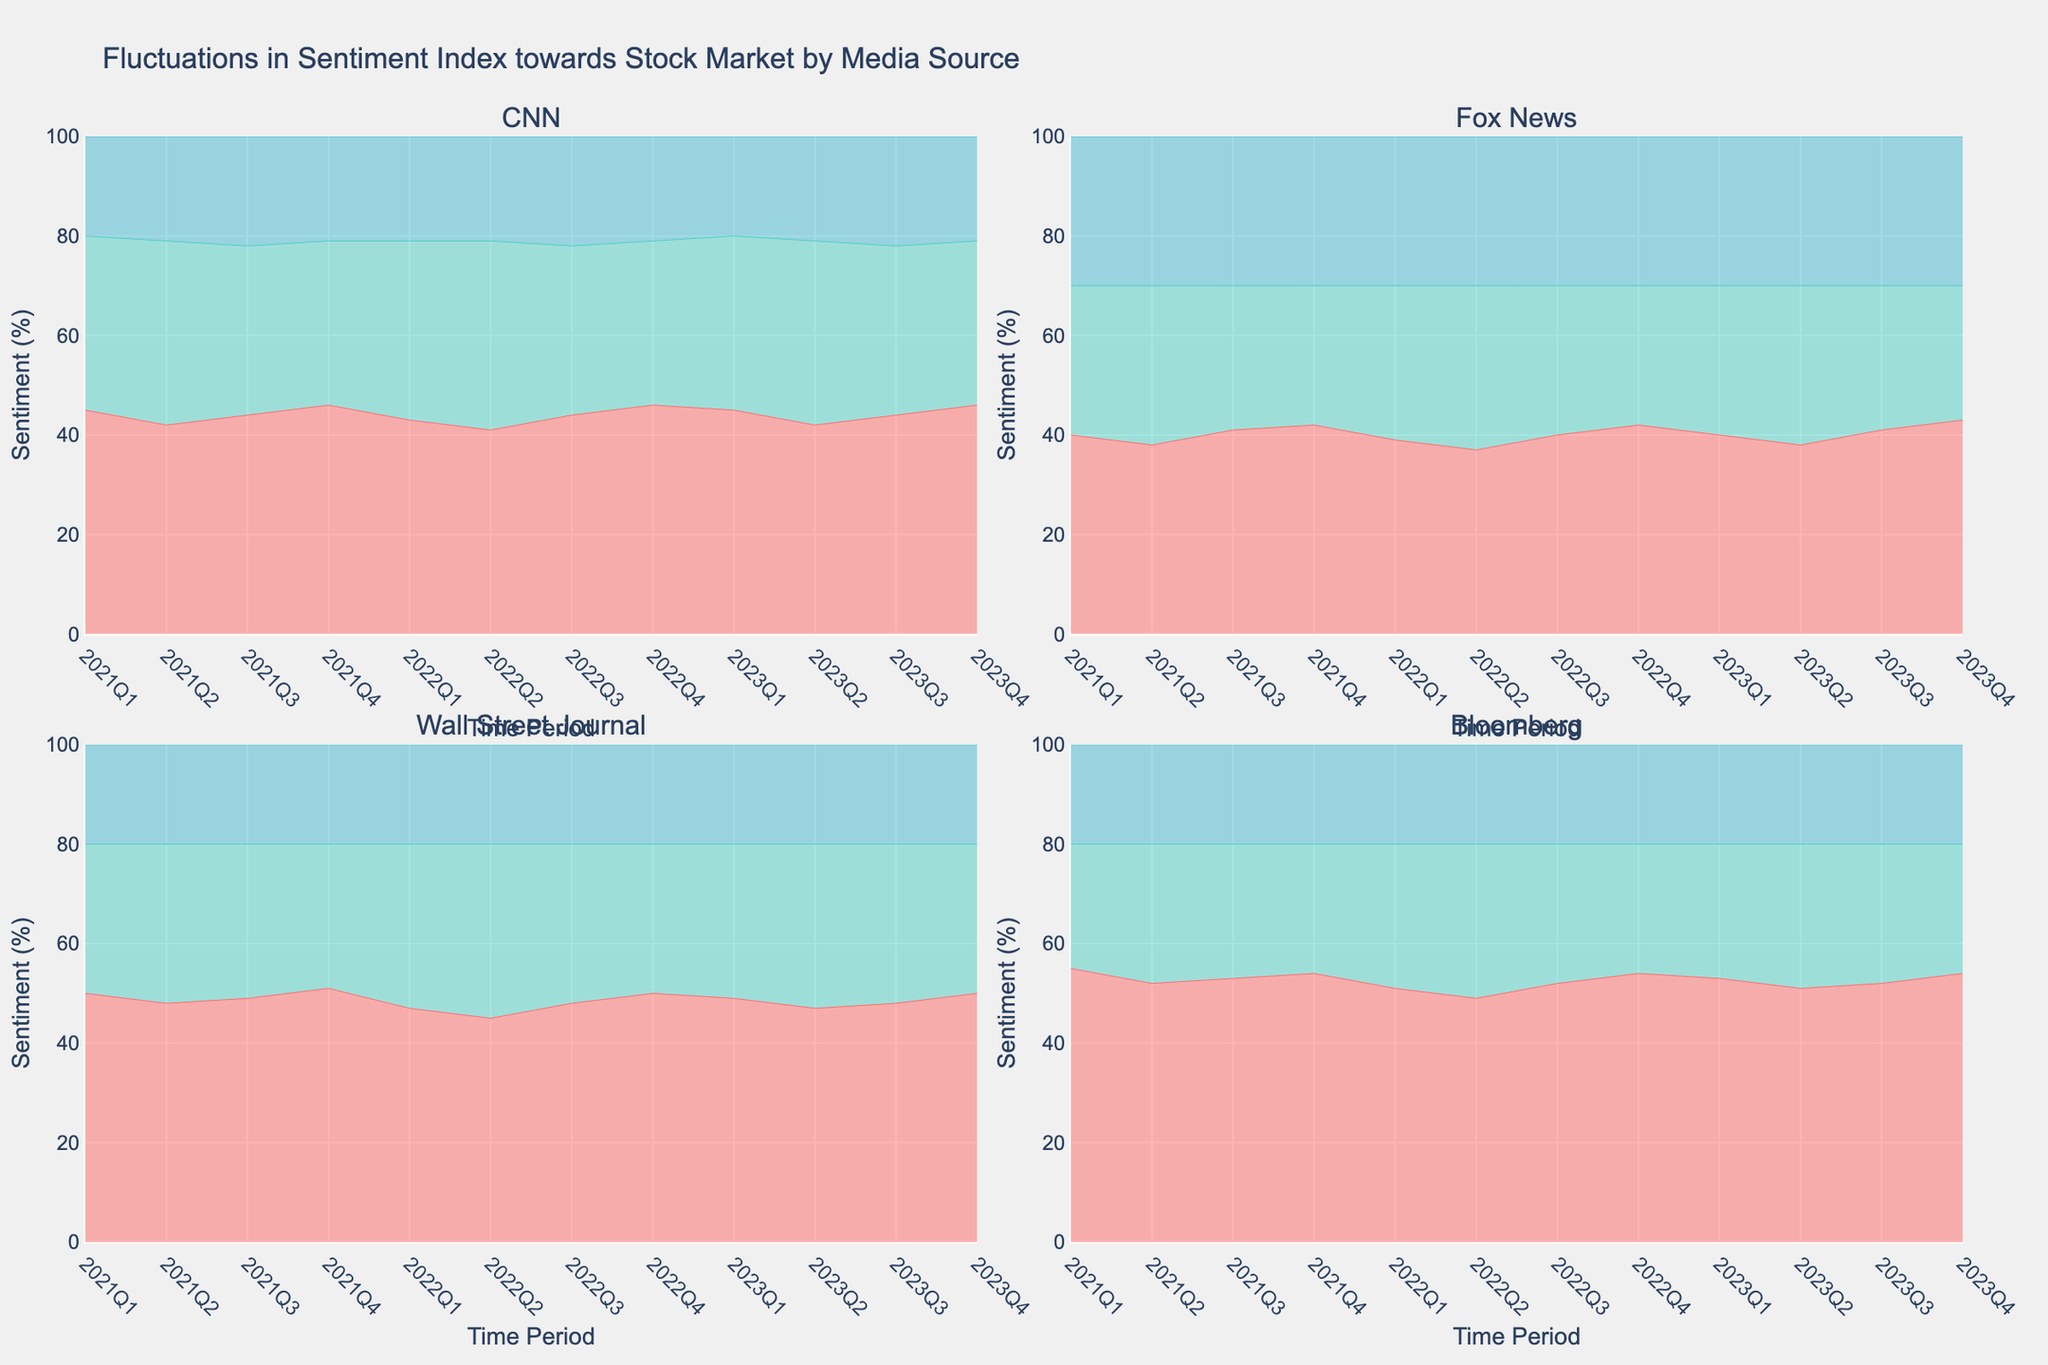What is the title of the figure? The title is found at the top of the figure, providing an overview of the visual content. It states the primary focus of the data analyzed in the subplots.
Answer: Fluctuations in Sentiment Index towards Stock Market by Media Source Which media source consistently shows the highest proportion of positive sentiment throughout the time periods? By examining each subplot, you can observe that Bloomberg maintains the highest levels of positive sentiment in comparison to CNN, Fox News, and Wall Street Journal across all time periods shown.
Answer: Bloomberg What is the general trend in negative sentiment for Fox News from 2021Q1 to 2023Q4? By following the negative sentiment line across the different time periods in Fox News’s subplot, you can see that the values do not fluctuate significantly, maintaining a generally consistent percentage across the years.
Answer: Consistent How does CNN’s neutral sentiment percentage in 2023Q4 compare to that in 2021Q1? Look at the 2023Q4 and 2021Q1 data on CNN’s subplot. Compare the height of the neutral sentiment area for these two periods, noting that CNN’s neutral sentiment decreases slightly from 2021Q1 (35%) to 2023Q4 (33%).
Answer: Decreased Which sentiment type shows the most significant fluctuation for the Wall Street Journal over the period analyzed? Observe the areas representing positive, neutral, and negative sentiments in the Wall Street Journal’s subplot. The neutral sentiment, which starts at 30% in 2021Q1 and varies more visibly in the mid periods before returning to the initial value around 2023Q4, shows the most significant fluctuation.
Answer: Neutral What is the average positive sentiment for Fox News over the entire time period shown? Calculate the positive sentiment for each quarter from 2021Q1 to 2023Q4, sum these values, and divide by the number of quarters: (40 + 38 + 41 + 42 + 39 + 37 + 40 + 42 + 40 + 38 + 41 + 43) / 12.
Answer: 40.08 Which media source has the largest difference in positive sentiment between any two consecutive quarters? Observe the area charts for each subplot and identify the quarters where the positive sentiment changes most drastically. The most significant difference in positive sentiment is noticed in Bloomberg’s subplot between 2021Q2 and 2021Q1, which drops from 55% to 52%, a 3% decrease.
Answer: Bloomberg Are there any time periods where all media sources show the same proportion of negative sentiment? Examine all subplots for each quarter and look for a common percentage in the negative sentiment areas. Notice that in every quarter, the negative sentiment for each media source differs, although some periods have more similar values.
Answer: No Comparing 2021Q4 and 2023Q4, which media source showed an increase in positive sentiment? By comparing the area representing positive sentiment for each media source in 2021Q4 and 2023Q4, you can see that Fox News increased its positive sentiment from 42% to 43%.
Answer: Fox News What color represents the neutral sentiment in the subplots? Refer to the legend at the bottom of the plot and identify the color associated with neutral sentiment. The color used in subplots to represent neutral sentiment is apparent in the area filling the middle portion between positive and negative sentiments.
Answer: Green 